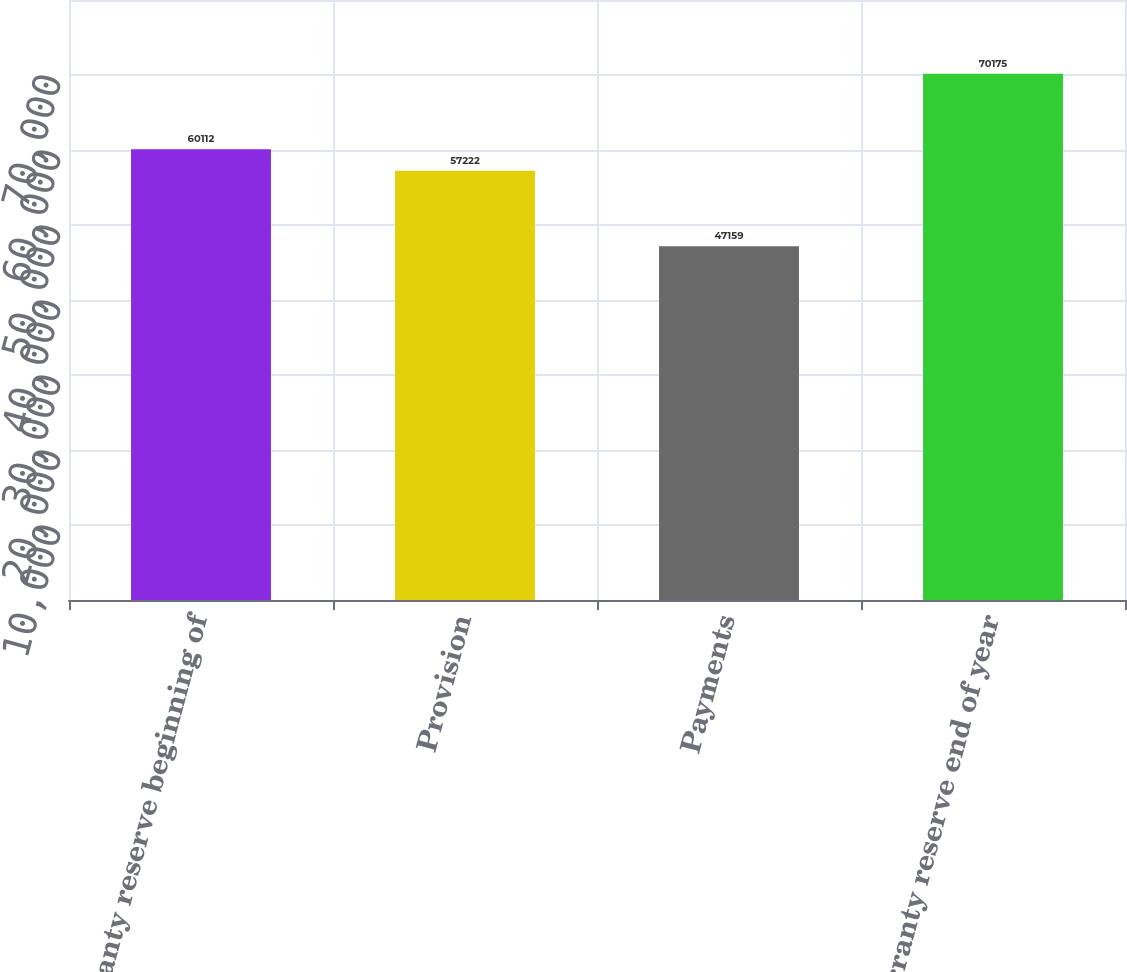Convert chart to OTSL. <chart><loc_0><loc_0><loc_500><loc_500><bar_chart><fcel>Warranty reserve beginning of<fcel>Provision<fcel>Payments<fcel>Warranty reserve end of year<nl><fcel>60112<fcel>57222<fcel>47159<fcel>70175<nl></chart> 